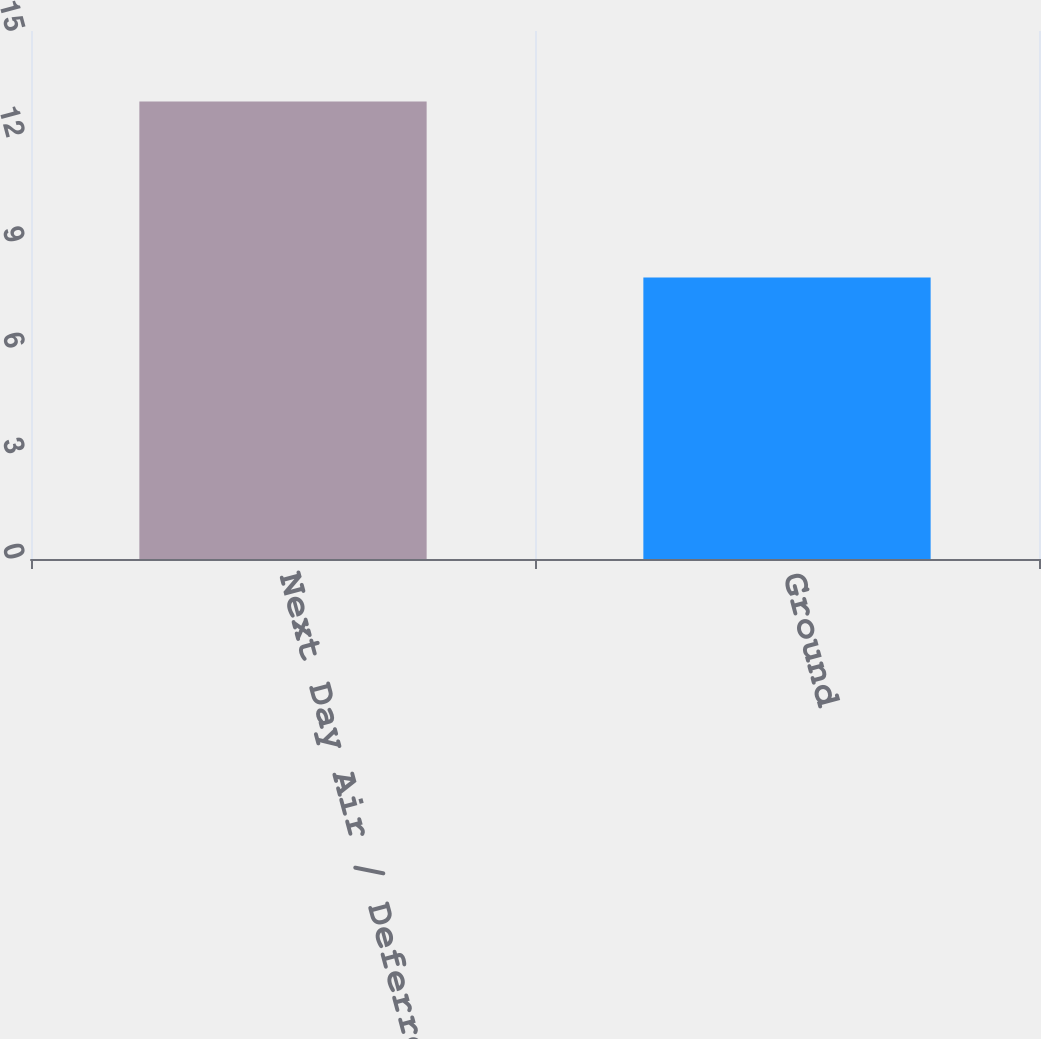<chart> <loc_0><loc_0><loc_500><loc_500><bar_chart><fcel>Next Day Air / Deferred<fcel>Ground<nl><fcel>13<fcel>8<nl></chart> 